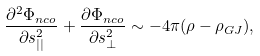Convert formula to latex. <formula><loc_0><loc_0><loc_500><loc_500>\frac { \partial ^ { 2 } \Phi _ { n c o } } { \partial s _ { | | } ^ { 2 } } + \frac { \partial \Phi _ { n c o } } { \partial s _ { \perp } ^ { 2 } } \sim - 4 \pi ( \rho - \rho _ { G J } ) ,</formula> 